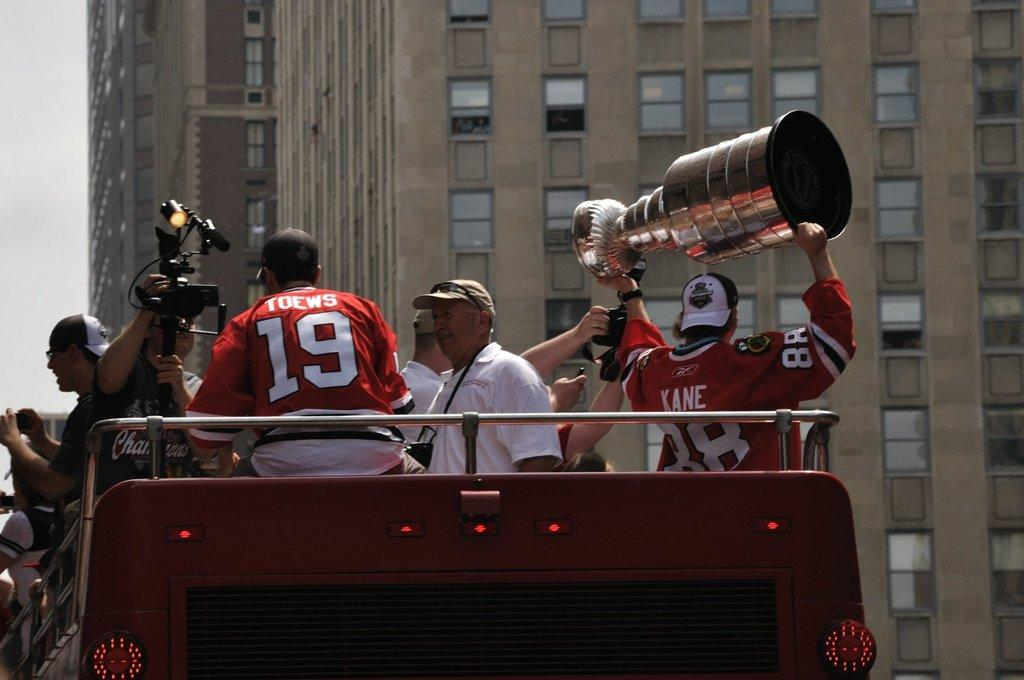<image>
Present a compact description of the photo's key features. A man lifts up a large trophy wearing a Kane jersey. 